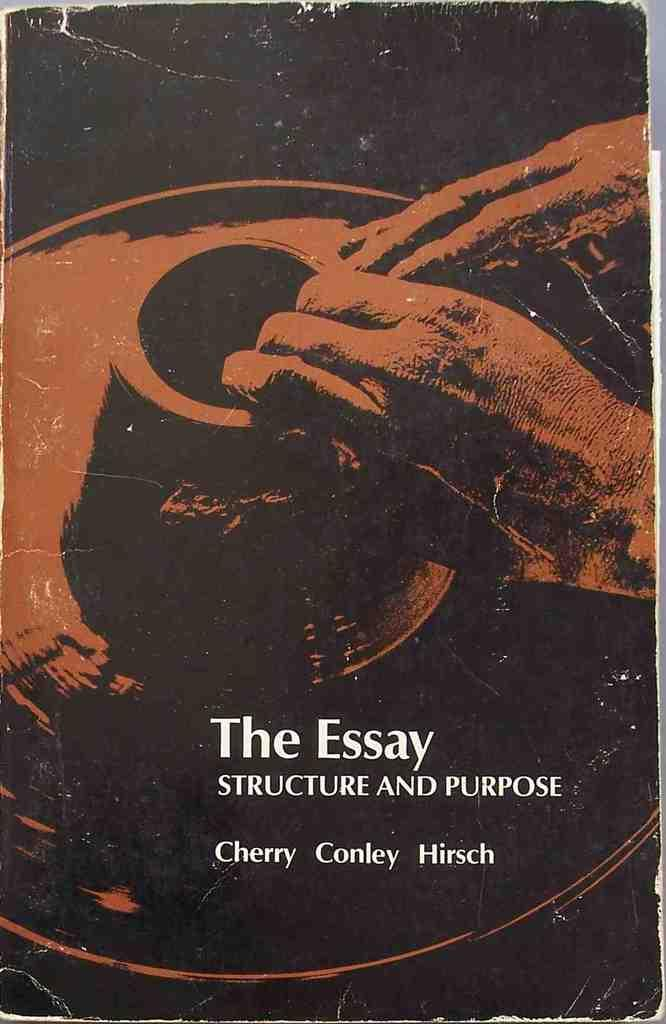<image>
Create a compact narrative representing the image presented. Cover of a book of someone making a clay pot named, "The Essay." 